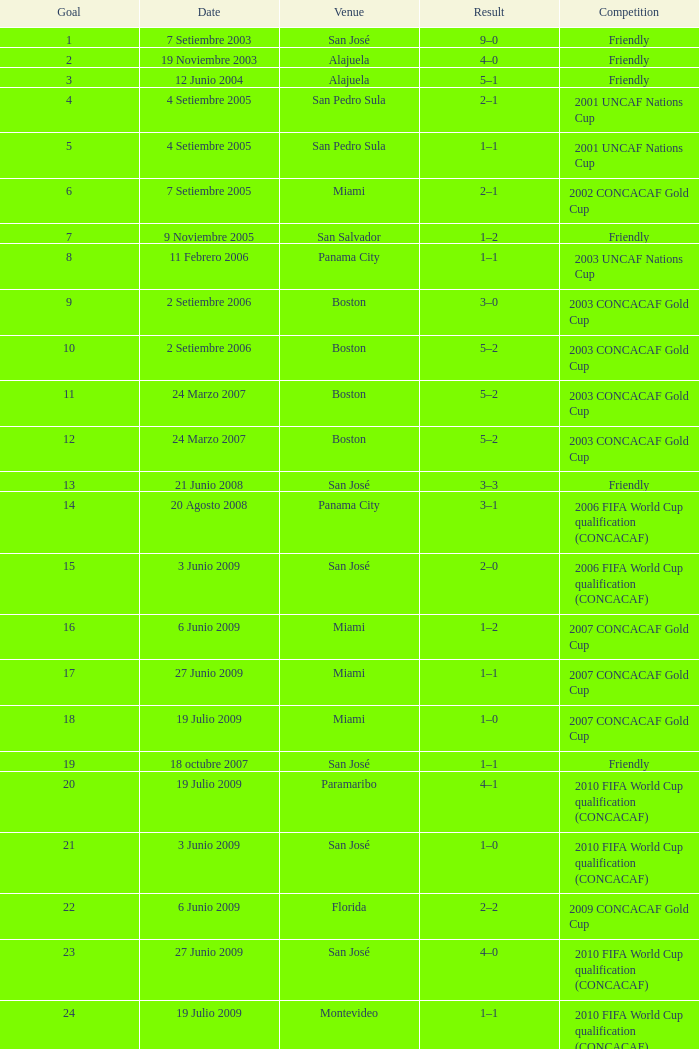How many goals were made on the date of june 21, 2008? 1.0. 